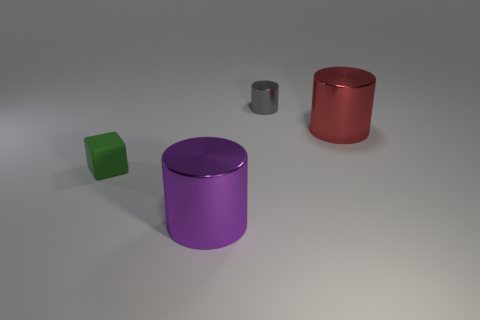Add 3 gray cylinders. How many objects exist? 7 Subtract all cylinders. How many objects are left? 1 Subtract all large purple shiny things. Subtract all red metal cubes. How many objects are left? 3 Add 3 big cylinders. How many big cylinders are left? 5 Add 1 cyan shiny balls. How many cyan shiny balls exist? 1 Subtract 0 gray balls. How many objects are left? 4 